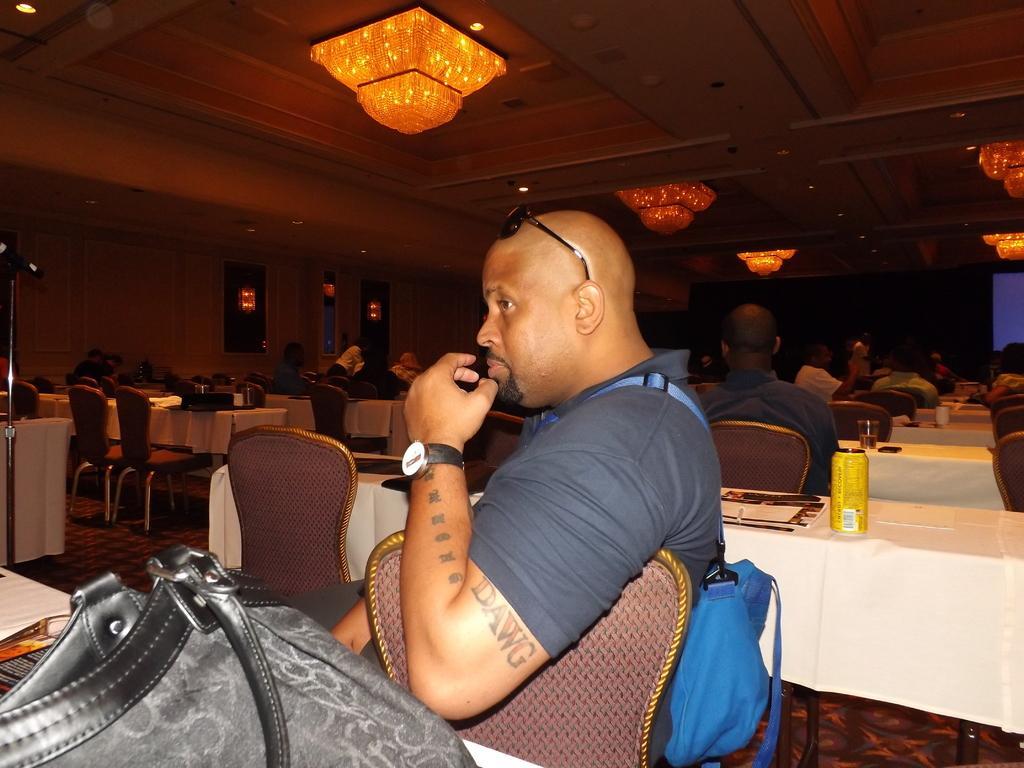Describe this image in one or two sentences. In this image I can see a man who is sitting on a chair in front of a table and there are other people who are sitting on a chair in front of a table. On the table we have a bag and other objects on it. 